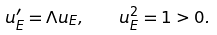<formula> <loc_0><loc_0><loc_500><loc_500>u _ { E } ^ { \prime } = \Lambda u _ { E } , \quad u _ { E } ^ { 2 } = 1 > 0 .</formula> 